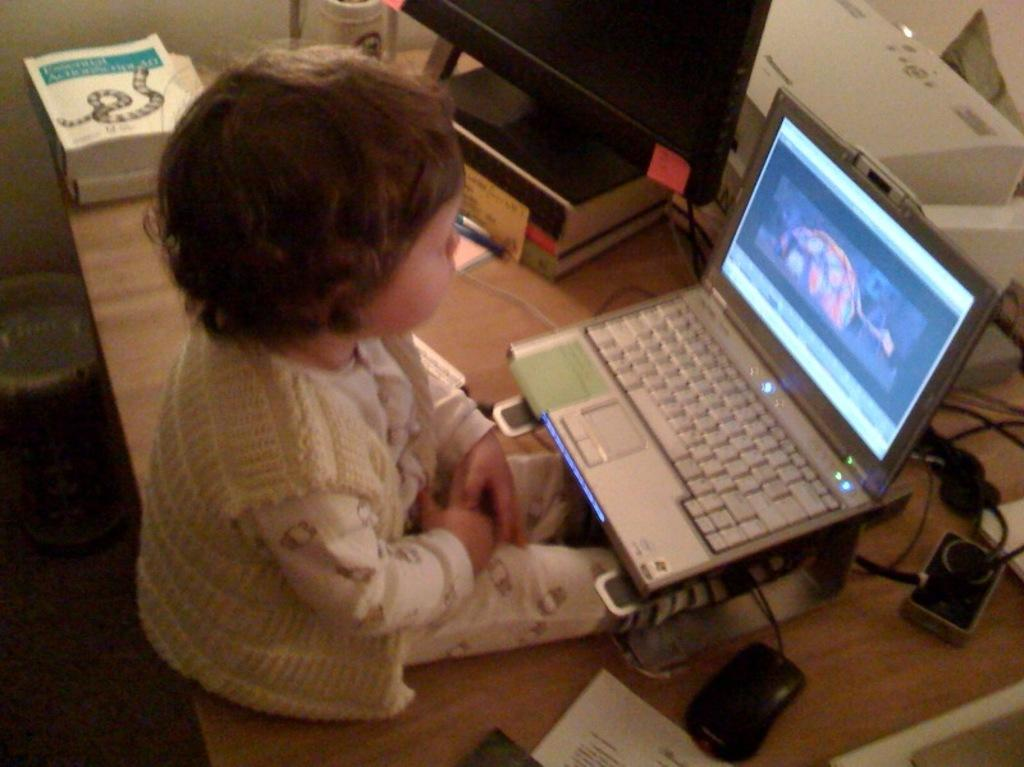What is the main subject of the image? The main subject of the image is a kid. What is the kid doing in the image? The kid is seated in front of a laptop. Where is the laptop placed in the image? The laptop is on a table. What is used for input with the laptop? There is a mouse beside the laptop. What else can be seen on the table in the image? There are books and other things on the table. How many people are in the group in the image? There is no group of people present in the image; it only features a kid using a laptop. What type of glass is being used to drink water in the image? There is no glass or water visible in the image. 